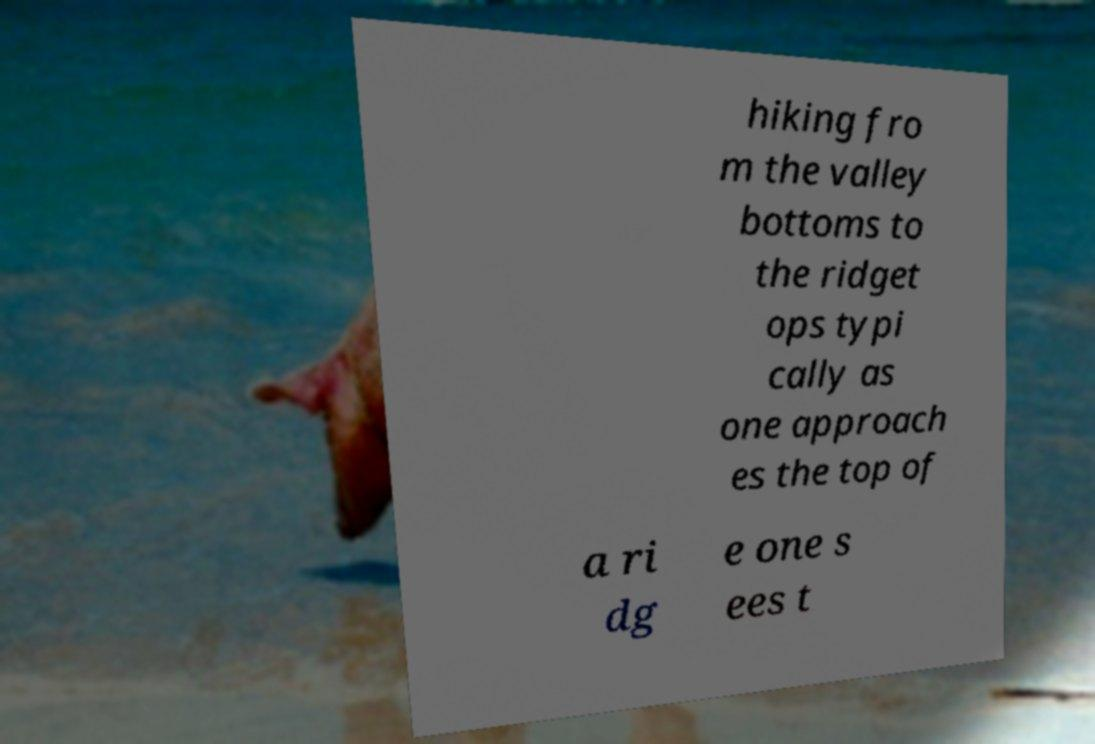Could you assist in decoding the text presented in this image and type it out clearly? hiking fro m the valley bottoms to the ridget ops typi cally as one approach es the top of a ri dg e one s ees t 